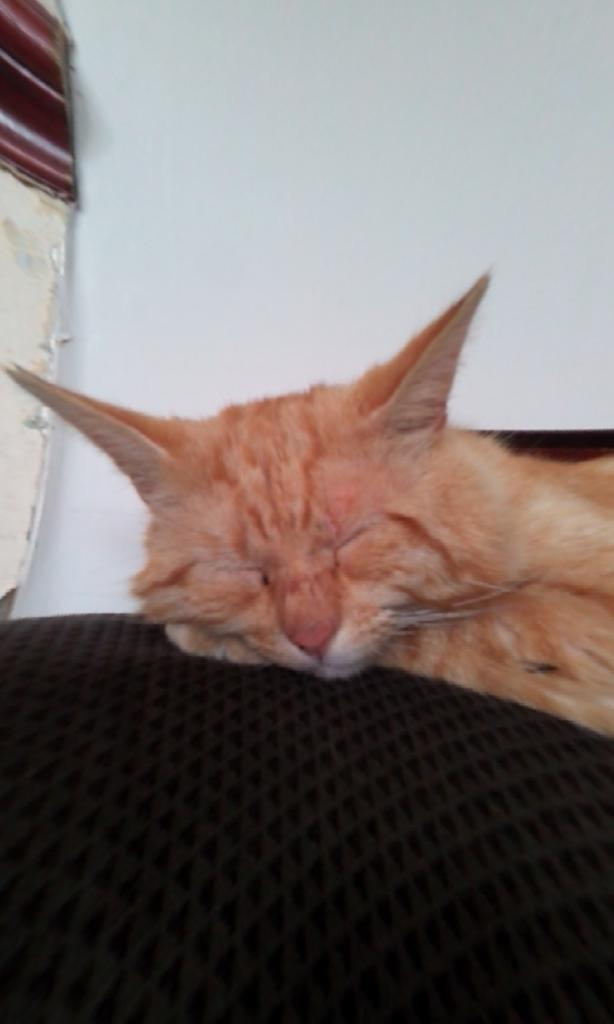What type of animal is on the sofa in the image? There is a cat on a sofa in the image. What can be seen in the background of the image? There is a wall in the background of the image. Can you describe the object in the top left of the image? Unfortunately, the facts provided do not give enough information to describe the object in the top left of the image. Is the cat in the image crushing any flowers in a garden? There is no garden or flowers present in the image, and the cat is not shown crushing anything. 